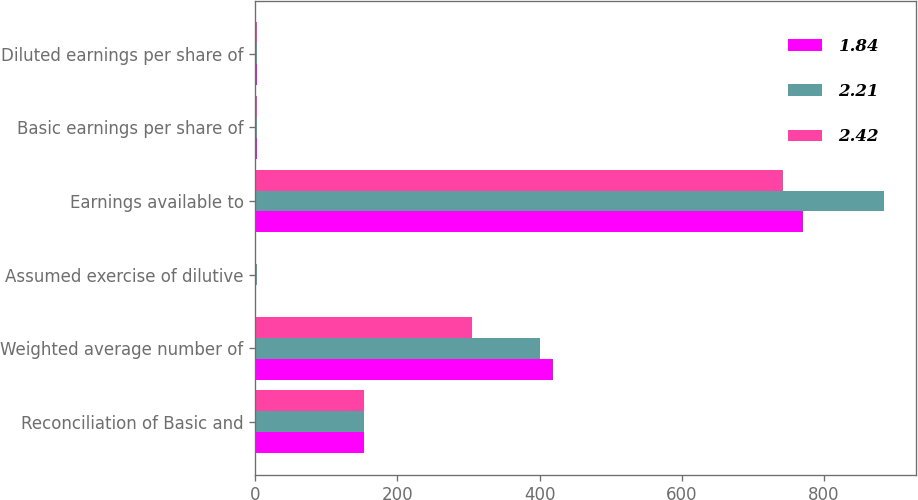Convert chart. <chart><loc_0><loc_0><loc_500><loc_500><stacked_bar_chart><ecel><fcel>Reconciliation of Basic and<fcel>Weighted average number of<fcel>Assumed exercise of dilutive<fcel>Earnings available to<fcel>Basic earnings per share of<fcel>Diluted earnings per share of<nl><fcel>1.84<fcel>153.22<fcel>419<fcel>1<fcel>770<fcel>1.85<fcel>1.84<nl><fcel>2.21<fcel>153.22<fcel>401<fcel>2<fcel>885<fcel>2.22<fcel>2.21<nl><fcel>2.42<fcel>153.22<fcel>305<fcel>1<fcel>742<fcel>2.44<fcel>2.42<nl></chart> 